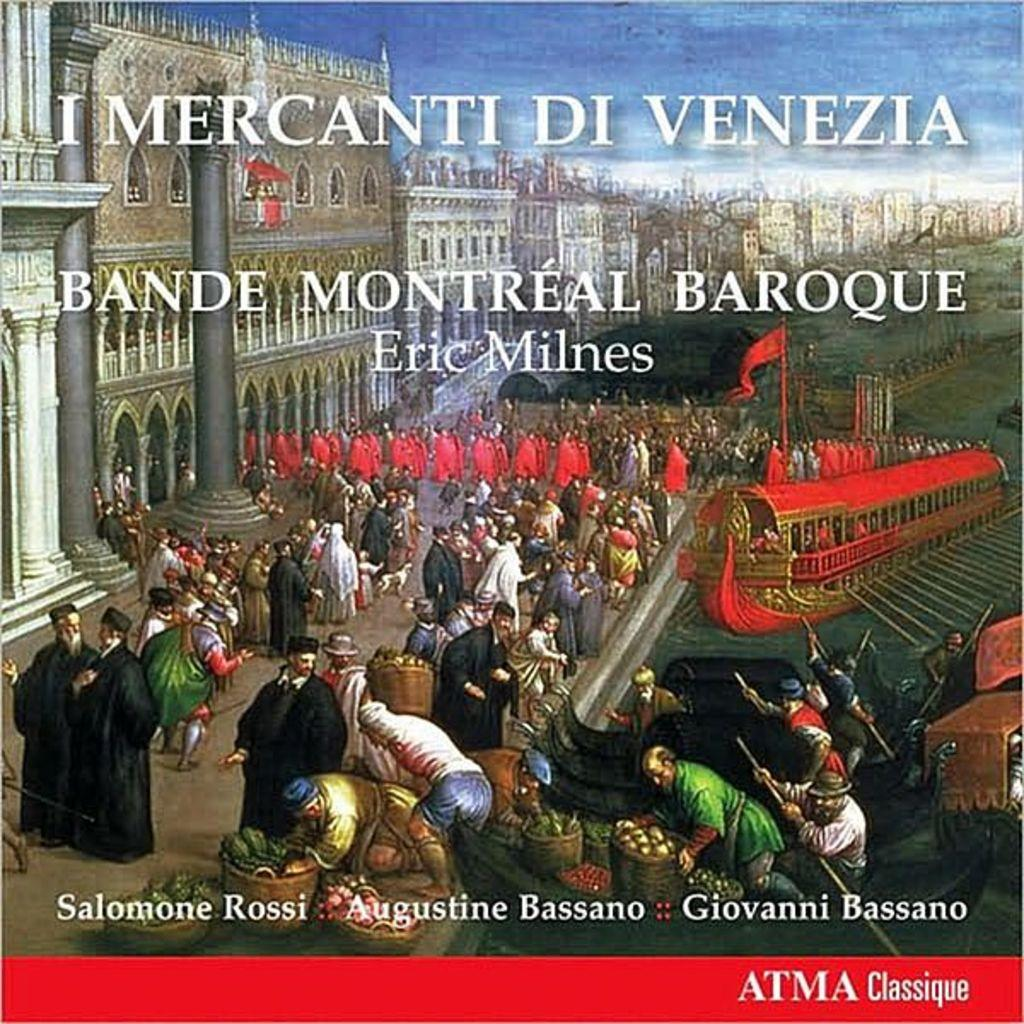<image>
Summarize the visual content of the image. Eric Milnes conducted a Baroque orchestra in Montreal. 